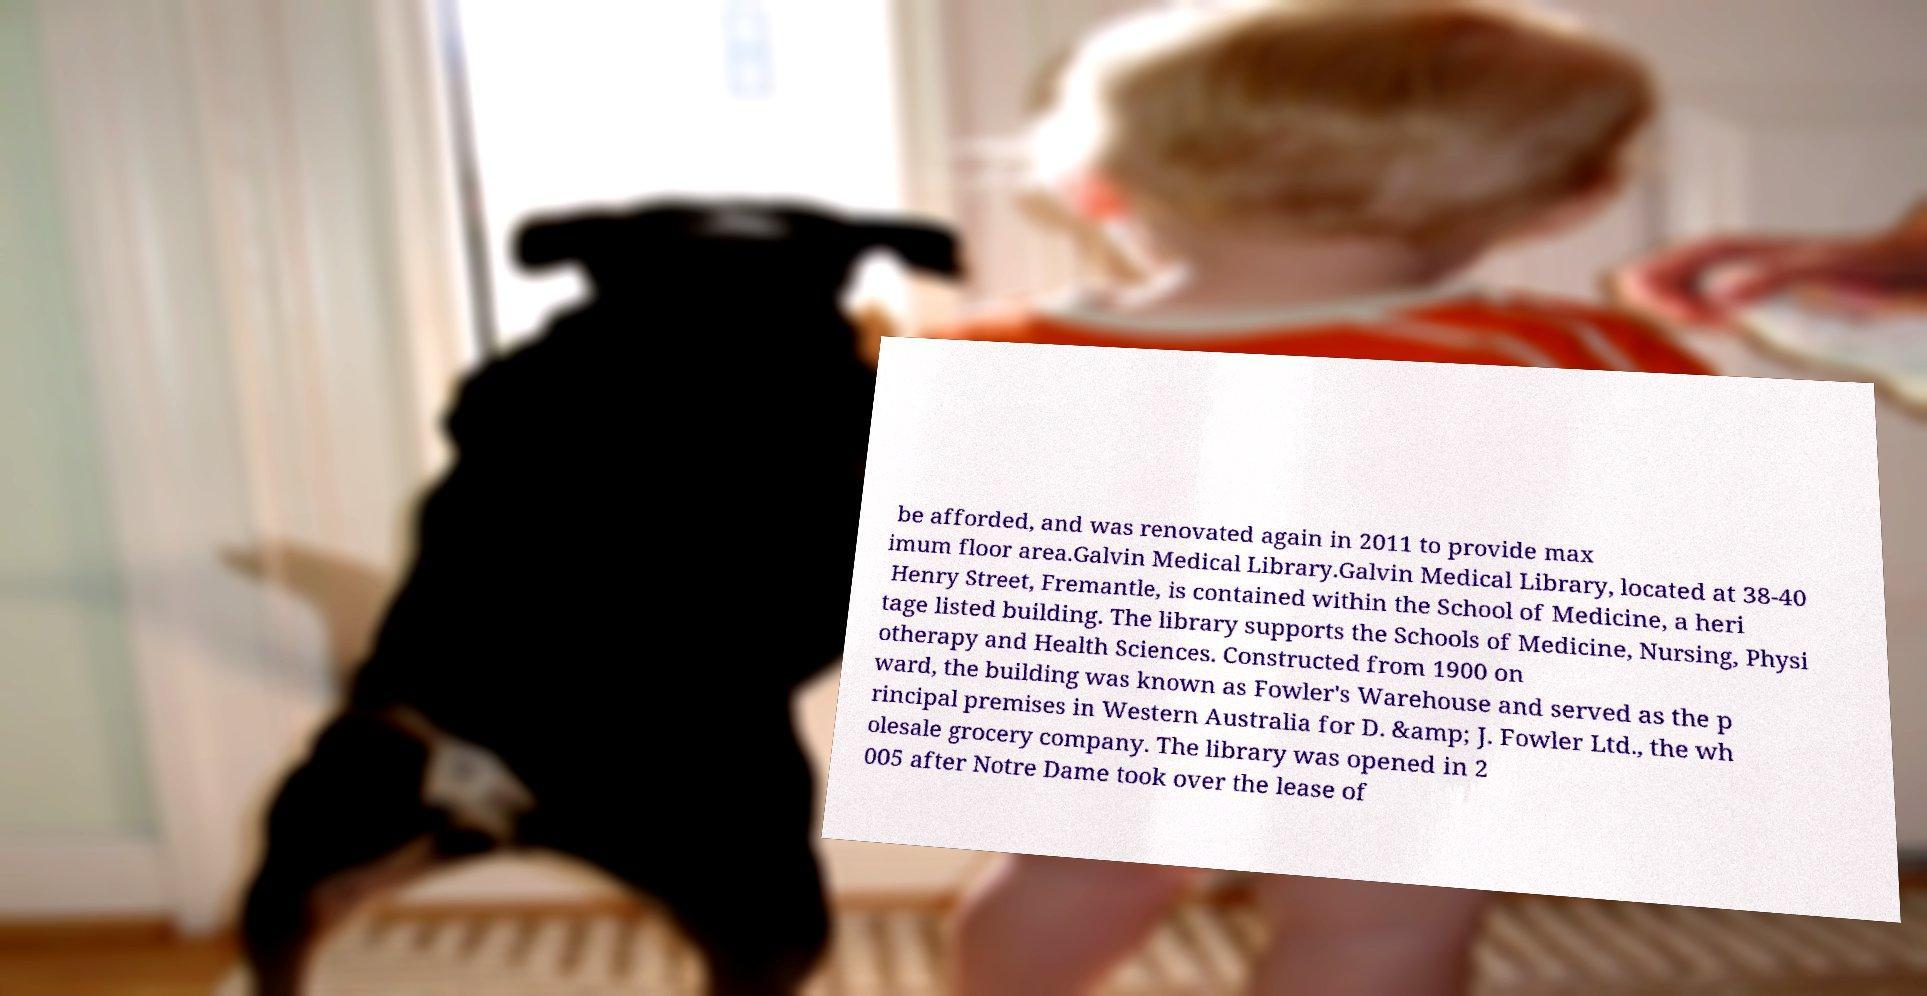What messages or text are displayed in this image? I need them in a readable, typed format. be afforded, and was renovated again in 2011 to provide max imum floor area.Galvin Medical Library.Galvin Medical Library, located at 38-40 Henry Street, Fremantle, is contained within the School of Medicine, a heri tage listed building. The library supports the Schools of Medicine, Nursing, Physi otherapy and Health Sciences. Constructed from 1900 on ward, the building was known as Fowler's Warehouse and served as the p rincipal premises in Western Australia for D. &amp; J. Fowler Ltd., the wh olesale grocery company. The library was opened in 2 005 after Notre Dame took over the lease of 